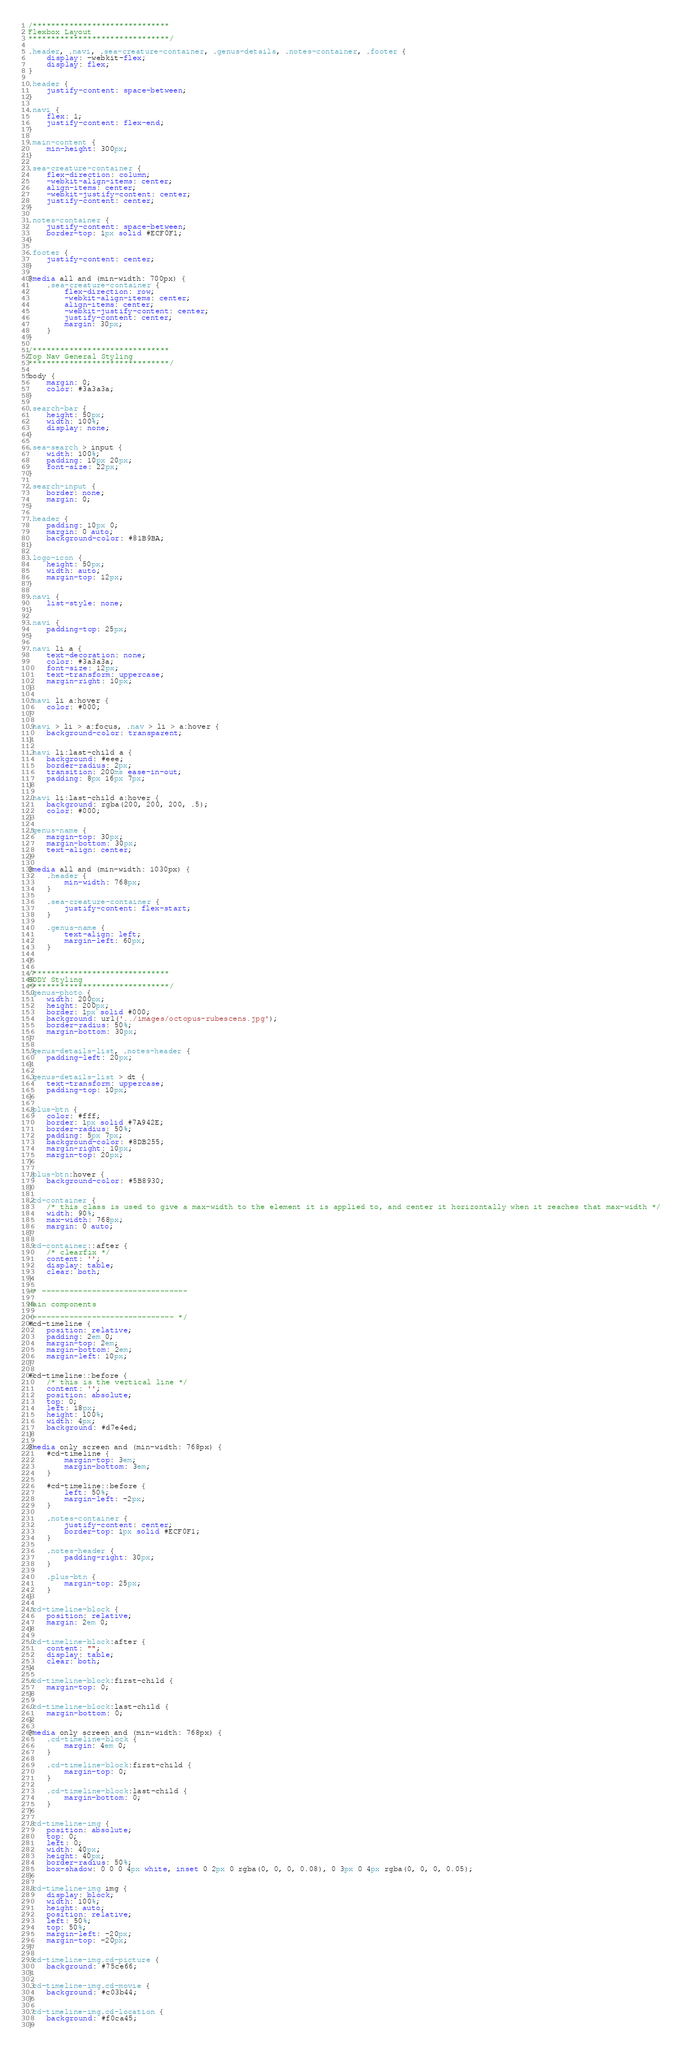Convert code to text. <code><loc_0><loc_0><loc_500><loc_500><_CSS_>/******************************
Flexbox Layout
*******************************/

.header, .navi, .sea-creature-container, .genus-details, .notes-container, .footer {
    display: -webkit-flex;
    display: flex;
}

.header {
    justify-content: space-between;
}

.navi {
    flex: 1;
    justify-content: flex-end;
}

.main-content {
    min-height: 300px;
}

.sea-creature-container {
    flex-direction: column;
    -webkit-align-items: center;
    align-items: center;
    -webkit-justify-content: center;
    justify-content: center;
}

.notes-container {
    justify-content: space-between;
    border-top: 1px solid #ECF0F1;
}

.footer {
    justify-content: center;
}

@media all and (min-width: 700px) {
    .sea-creature-container {
        flex-direction: row;
        -webkit-align-items: center;
        align-items: center;
        -webkit-justify-content: center;
        justify-content: center;
        margin: 30px;
    }
}

/******************************
Top Nav General Styling
*******************************/

body {
    margin: 0;
    color: #3a3a3a;
}

.search-bar {
    height: 50px;
    width: 100%;
    display: none;
}

.sea-search > input {
    width: 100%;
    padding: 10px 20px;
    font-size: 22px;
}

.search-input {
    border: none;
    margin: 0;
}

.header {
    padding: 10px 0;
    margin: 0 auto;
    background-color: #81B9BA;
}

.logo-icon {
    height: 50px;
    width: auto;
    margin-top: 12px;
}

.navi {
    list-style: none;
}

.navi {
    padding-top: 25px;
}

.navi li a {
    text-decoration: none;
    color: #3a3a3a;
    font-size: 12px;
    text-transform: uppercase;
    margin-right: 10px;
}

.navi li a:hover {
    color: #000;
}

.navi > li > a:focus, .nav > li > a:hover {
    background-color: transparent;
}

.navi li:last-child a {
    background: #eee;
    border-radius: 2px;
    transition: 200ms ease-in-out;
    padding: 8px 16px 7px;
}

.navi li:last-child a:hover {
    background: rgba(200, 200, 200, .5);
    color: #000;
}

.genus-name {
    margin-top: 30px;
    margin-bottom: 30px;
    text-align: center;
}

@media all and (min-width: 1030px) {
    .header {
        min-width: 768px;
    }

    .sea-creature-container {
        justify-content: flex-start;
    }

    .genus-name {
        text-align: left;
        margin-left: 60px;
    }

}

/******************************
BODY Styling
*******************************/
.genus-photo {
    width: 200px;
    height: 200px;
    border: 1px solid #000;
    background: url('../images/octopus-rubescens.jpg');
    border-radius: 50%;
    margin-bottom: 30px;
}

.genus-details-list, .notes-header {
    padding-left: 20px;
}

.genus-details-list > dt {
    text-transform: uppercase;
    padding-top: 10px;
}

.plus-btn {
    color: #fff;
    border: 1px solid #7A942E;
    border-radius: 50%;
    padding: 5px 7px;
    background-color: #8DB255;
    margin-right: 10px;
    margin-top: 20px;
}

.plus-btn:hover {
    background-color: #5B8930;
}

.cd-container {
    /* this class is used to give a max-width to the element it is applied to, and center it horizontally when it reaches that max-width */
    width: 90%;
    max-width: 768px;
    margin: 0 auto;
}

.cd-container::after {
    /* clearfix */
    content: '';
    display: table;
    clear: both;
}

/* --------------------------------

Main components

-------------------------------- */
#cd-timeline {
    position: relative;
    padding: 2em 0;
    margin-top: 2em;
    margin-bottom: 2em;
    margin-left: 10px;
}

#cd-timeline::before {
    /* this is the vertical line */
    content: '';
    position: absolute;
    top: 0;
    left: 18px;
    height: 100%;
    width: 4px;
    background: #d7e4ed;
}

@media only screen and (min-width: 768px) {
    #cd-timeline {
        margin-top: 3em;
        margin-bottom: 3em;
    }

    #cd-timeline::before {
        left: 50%;
        margin-left: -2px;
    }

    .notes-container {
        justify-content: center;
        border-top: 1px solid #ECF0F1;
    }

    .notes-header {
        padding-right: 30px;
    }

    .plus-btn {
        margin-top: 25px;
    }
}

.cd-timeline-block {
    position: relative;
    margin: 2em 0;
}

.cd-timeline-block:after {
    content: "";
    display: table;
    clear: both;
}

.cd-timeline-block:first-child {
    margin-top: 0;
}

.cd-timeline-block:last-child {
    margin-bottom: 0;
}

@media only screen and (min-width: 768px) {
    .cd-timeline-block {
        margin: 4em 0;
    }

    .cd-timeline-block:first-child {
        margin-top: 0;
    }

    .cd-timeline-block:last-child {
        margin-bottom: 0;
    }
}

.cd-timeline-img {
    position: absolute;
    top: 0;
    left: 0;
    width: 40px;
    height: 40px;
    border-radius: 50%;
    box-shadow: 0 0 0 4px white, inset 0 2px 0 rgba(0, 0, 0, 0.08), 0 3px 0 4px rgba(0, 0, 0, 0.05);
}

.cd-timeline-img img {
    display: block;
    width: 100%;
    height: auto;
    position: relative;
    left: 50%;
    top: 50%;
    margin-left: -20px;
    margin-top: -20px;
}

.cd-timeline-img.cd-picture {
    background: #75ce66;
}

.cd-timeline-img.cd-movie {
    background: #c03b44;
}

.cd-timeline-img.cd-location {
    background: #f0ca45;
}
</code> 